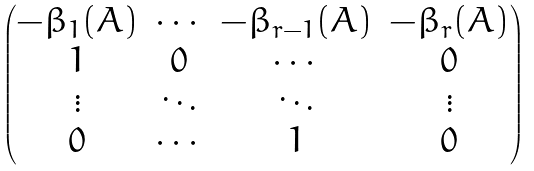<formula> <loc_0><loc_0><loc_500><loc_500>\begin{pmatrix} - \beta _ { 1 } ( A ) & \cdots & - \beta _ { r - 1 } ( A ) & - \beta _ { r } ( A ) \\ 1 & 0 & \cdots & 0 \\ \vdots & \ddots & \ddots & \vdots \\ 0 & \cdots & 1 & 0 \end{pmatrix}</formula> 